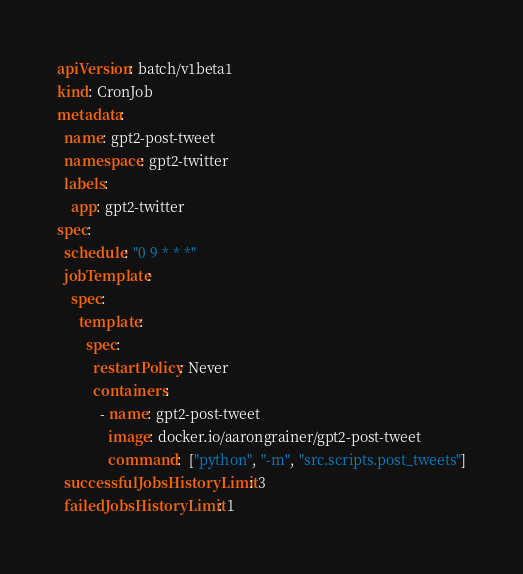Convert code to text. <code><loc_0><loc_0><loc_500><loc_500><_YAML_>apiVersion: batch/v1beta1
kind: CronJob
metadata:
  name: gpt2-post-tweet
  namespace: gpt2-twitter
  labels:
    app: gpt2-twitter
spec:
  schedule: "0 9 * * *"
  jobTemplate:
    spec:
      template:
        spec:
          restartPolicy: Never
          containers:
            - name: gpt2-post-tweet
              image: docker.io/aarongrainer/gpt2-post-tweet
              command:  ["python", "-m", "src.scripts.post_tweets"]
  successfulJobsHistoryLimit: 3
  failedJobsHistoryLimit: 1
</code> 